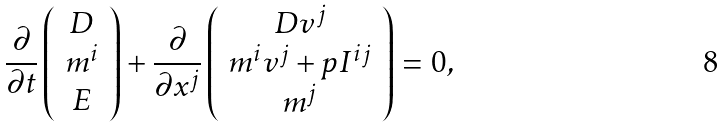<formula> <loc_0><loc_0><loc_500><loc_500>\frac { \partial } { \partial t } \left ( \begin{array} { c } D \\ m ^ { i } \\ E \end{array} \right ) + \frac { \partial } { \partial x ^ { j } } \left ( \begin{array} { c } D v ^ { j } \\ m ^ { i } v ^ { j } + p I ^ { i j } \\ m ^ { j } \\ \end{array} \right ) = 0 ,</formula> 